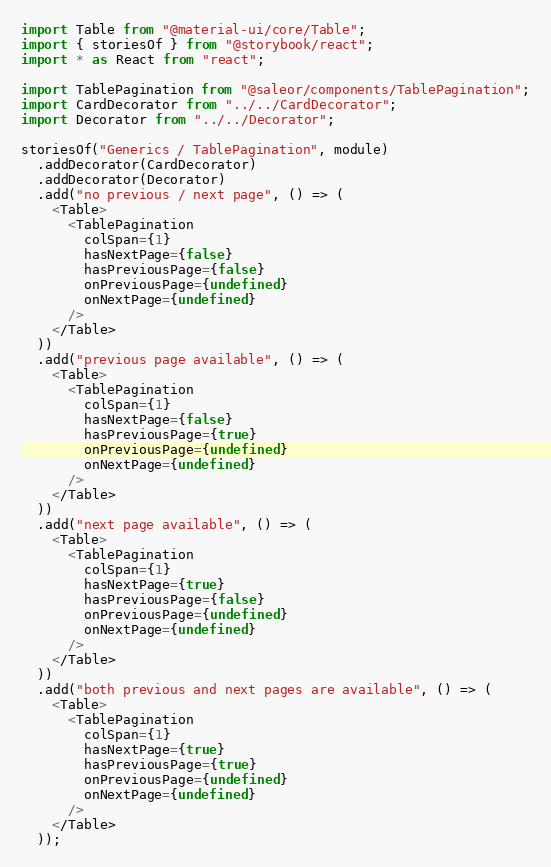Convert code to text. <code><loc_0><loc_0><loc_500><loc_500><_TypeScript_>import Table from "@material-ui/core/Table";
import { storiesOf } from "@storybook/react";
import * as React from "react";

import TablePagination from "@saleor/components/TablePagination";
import CardDecorator from "../../CardDecorator";
import Decorator from "../../Decorator";

storiesOf("Generics / TablePagination", module)
  .addDecorator(CardDecorator)
  .addDecorator(Decorator)
  .add("no previous / next page", () => (
    <Table>
      <TablePagination
        colSpan={1}
        hasNextPage={false}
        hasPreviousPage={false}
        onPreviousPage={undefined}
        onNextPage={undefined}
      />
    </Table>
  ))
  .add("previous page available", () => (
    <Table>
      <TablePagination
        colSpan={1}
        hasNextPage={false}
        hasPreviousPage={true}
        onPreviousPage={undefined}
        onNextPage={undefined}
      />
    </Table>
  ))
  .add("next page available", () => (
    <Table>
      <TablePagination
        colSpan={1}
        hasNextPage={true}
        hasPreviousPage={false}
        onPreviousPage={undefined}
        onNextPage={undefined}
      />
    </Table>
  ))
  .add("both previous and next pages are available", () => (
    <Table>
      <TablePagination
        colSpan={1}
        hasNextPage={true}
        hasPreviousPage={true}
        onPreviousPage={undefined}
        onNextPage={undefined}
      />
    </Table>
  ));
</code> 